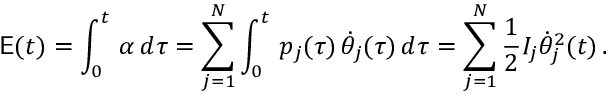Convert formula to latex. <formula><loc_0><loc_0><loc_500><loc_500>E ( t ) = \int _ { 0 } ^ { t } \, \alpha \, d \tau = \sum _ { j = 1 } ^ { N } \int _ { 0 } ^ { t } \, p _ { j } ( \tau ) \, \dot { \theta } _ { j } ( \tau ) \, d \tau = \sum _ { j = 1 } ^ { N } \frac { 1 } { 2 } I _ { j } \dot { \theta } _ { j } ^ { 2 } ( t ) \, .</formula> 